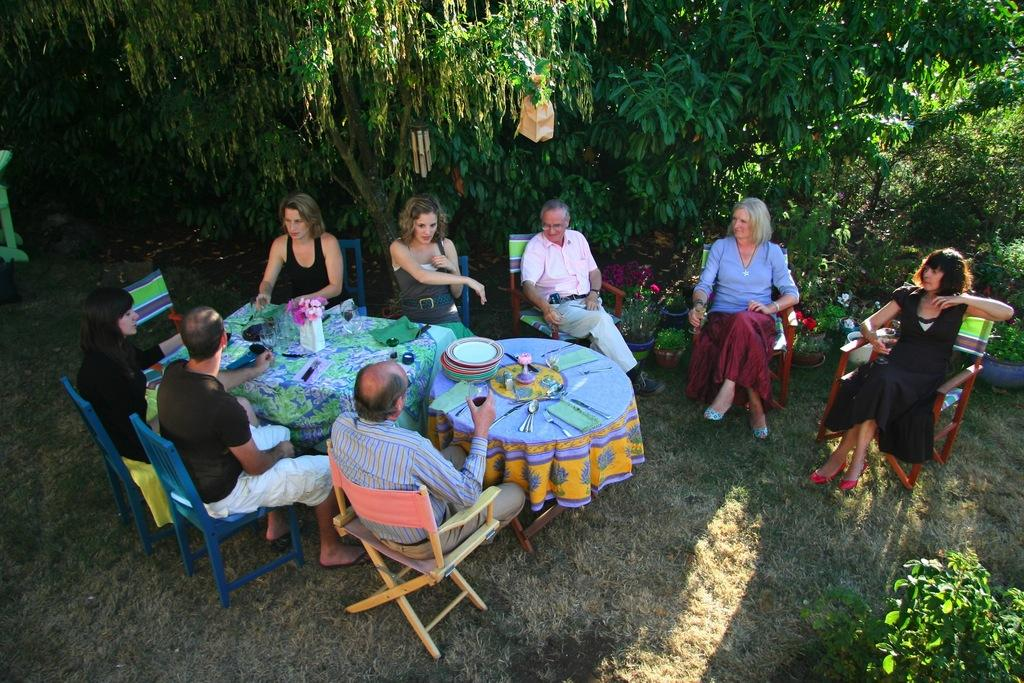What is happening in the image involving a group of people? In the image, there is a group of people seated on chairs. What can be found on the table in the image? On the table, there are plants and flowers. What is visible in the background of the image? Trees are visible in the image. How far away is the wound from the mitten in the image? There is no wound or mitten present in the image. 